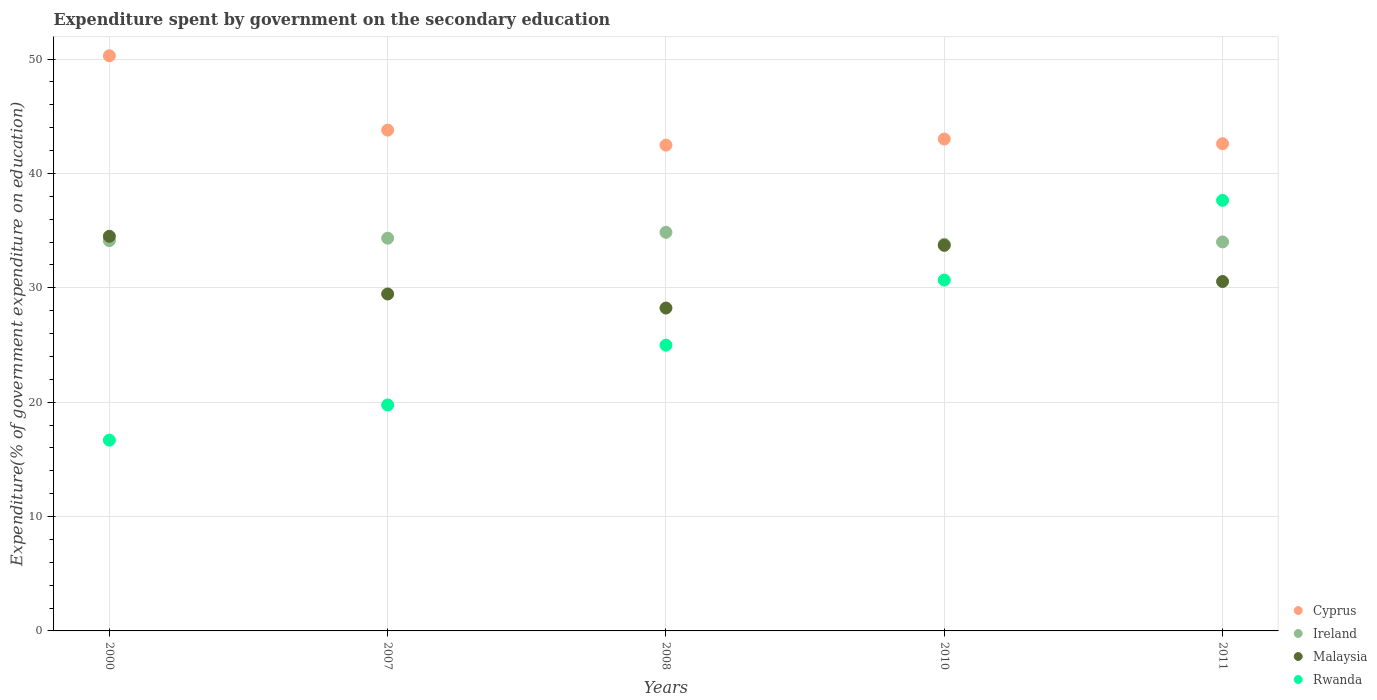What is the expenditure spent by government on the secondary education in Ireland in 2010?
Make the answer very short. 33.81. Across all years, what is the maximum expenditure spent by government on the secondary education in Rwanda?
Offer a very short reply. 37.65. Across all years, what is the minimum expenditure spent by government on the secondary education in Rwanda?
Make the answer very short. 16.68. In which year was the expenditure spent by government on the secondary education in Cyprus maximum?
Make the answer very short. 2000. In which year was the expenditure spent by government on the secondary education in Malaysia minimum?
Make the answer very short. 2008. What is the total expenditure spent by government on the secondary education in Cyprus in the graph?
Your answer should be compact. 222.17. What is the difference between the expenditure spent by government on the secondary education in Cyprus in 2000 and that in 2010?
Your answer should be very brief. 7.28. What is the difference between the expenditure spent by government on the secondary education in Ireland in 2008 and the expenditure spent by government on the secondary education in Rwanda in 2010?
Offer a very short reply. 4.18. What is the average expenditure spent by government on the secondary education in Rwanda per year?
Provide a short and direct response. 25.95. In the year 2000, what is the difference between the expenditure spent by government on the secondary education in Rwanda and expenditure spent by government on the secondary education in Ireland?
Your answer should be compact. -17.44. What is the ratio of the expenditure spent by government on the secondary education in Cyprus in 2000 to that in 2011?
Provide a short and direct response. 1.18. What is the difference between the highest and the second highest expenditure spent by government on the secondary education in Cyprus?
Your answer should be very brief. 6.5. What is the difference between the highest and the lowest expenditure spent by government on the secondary education in Ireland?
Make the answer very short. 1.04. Is it the case that in every year, the sum of the expenditure spent by government on the secondary education in Rwanda and expenditure spent by government on the secondary education in Malaysia  is greater than the expenditure spent by government on the secondary education in Ireland?
Your response must be concise. Yes. Does the expenditure spent by government on the secondary education in Malaysia monotonically increase over the years?
Ensure brevity in your answer.  No. How many dotlines are there?
Give a very brief answer. 4. How many years are there in the graph?
Offer a terse response. 5. Are the values on the major ticks of Y-axis written in scientific E-notation?
Give a very brief answer. No. How many legend labels are there?
Provide a short and direct response. 4. How are the legend labels stacked?
Your answer should be very brief. Vertical. What is the title of the graph?
Your answer should be very brief. Expenditure spent by government on the secondary education. Does "Cambodia" appear as one of the legend labels in the graph?
Your answer should be very brief. No. What is the label or title of the X-axis?
Your answer should be compact. Years. What is the label or title of the Y-axis?
Ensure brevity in your answer.  Expenditure(% of government expenditure on education). What is the Expenditure(% of government expenditure on education) in Cyprus in 2000?
Offer a terse response. 50.29. What is the Expenditure(% of government expenditure on education) in Ireland in 2000?
Provide a short and direct response. 34.13. What is the Expenditure(% of government expenditure on education) of Malaysia in 2000?
Make the answer very short. 34.51. What is the Expenditure(% of government expenditure on education) of Rwanda in 2000?
Provide a short and direct response. 16.68. What is the Expenditure(% of government expenditure on education) in Cyprus in 2007?
Keep it short and to the point. 43.79. What is the Expenditure(% of government expenditure on education) of Ireland in 2007?
Give a very brief answer. 34.34. What is the Expenditure(% of government expenditure on education) in Malaysia in 2007?
Make the answer very short. 29.46. What is the Expenditure(% of government expenditure on education) in Rwanda in 2007?
Your response must be concise. 19.76. What is the Expenditure(% of government expenditure on education) of Cyprus in 2008?
Your response must be concise. 42.48. What is the Expenditure(% of government expenditure on education) in Ireland in 2008?
Ensure brevity in your answer.  34.86. What is the Expenditure(% of government expenditure on education) of Malaysia in 2008?
Offer a terse response. 28.23. What is the Expenditure(% of government expenditure on education) in Rwanda in 2008?
Provide a short and direct response. 24.99. What is the Expenditure(% of government expenditure on education) in Cyprus in 2010?
Make the answer very short. 43.01. What is the Expenditure(% of government expenditure on education) in Ireland in 2010?
Provide a short and direct response. 33.81. What is the Expenditure(% of government expenditure on education) of Malaysia in 2010?
Your answer should be very brief. 33.72. What is the Expenditure(% of government expenditure on education) in Rwanda in 2010?
Keep it short and to the point. 30.68. What is the Expenditure(% of government expenditure on education) of Cyprus in 2011?
Keep it short and to the point. 42.6. What is the Expenditure(% of government expenditure on education) of Ireland in 2011?
Ensure brevity in your answer.  34.02. What is the Expenditure(% of government expenditure on education) in Malaysia in 2011?
Provide a short and direct response. 30.55. What is the Expenditure(% of government expenditure on education) of Rwanda in 2011?
Provide a short and direct response. 37.65. Across all years, what is the maximum Expenditure(% of government expenditure on education) in Cyprus?
Ensure brevity in your answer.  50.29. Across all years, what is the maximum Expenditure(% of government expenditure on education) in Ireland?
Provide a short and direct response. 34.86. Across all years, what is the maximum Expenditure(% of government expenditure on education) of Malaysia?
Ensure brevity in your answer.  34.51. Across all years, what is the maximum Expenditure(% of government expenditure on education) in Rwanda?
Offer a very short reply. 37.65. Across all years, what is the minimum Expenditure(% of government expenditure on education) in Cyprus?
Your answer should be compact. 42.48. Across all years, what is the minimum Expenditure(% of government expenditure on education) in Ireland?
Your answer should be very brief. 33.81. Across all years, what is the minimum Expenditure(% of government expenditure on education) of Malaysia?
Keep it short and to the point. 28.23. Across all years, what is the minimum Expenditure(% of government expenditure on education) of Rwanda?
Your response must be concise. 16.68. What is the total Expenditure(% of government expenditure on education) of Cyprus in the graph?
Ensure brevity in your answer.  222.17. What is the total Expenditure(% of government expenditure on education) of Ireland in the graph?
Your answer should be compact. 171.15. What is the total Expenditure(% of government expenditure on education) of Malaysia in the graph?
Offer a very short reply. 156.48. What is the total Expenditure(% of government expenditure on education) of Rwanda in the graph?
Offer a very short reply. 129.76. What is the difference between the Expenditure(% of government expenditure on education) in Cyprus in 2000 and that in 2007?
Your response must be concise. 6.5. What is the difference between the Expenditure(% of government expenditure on education) in Ireland in 2000 and that in 2007?
Provide a short and direct response. -0.21. What is the difference between the Expenditure(% of government expenditure on education) of Malaysia in 2000 and that in 2007?
Keep it short and to the point. 5.04. What is the difference between the Expenditure(% of government expenditure on education) of Rwanda in 2000 and that in 2007?
Your response must be concise. -3.08. What is the difference between the Expenditure(% of government expenditure on education) of Cyprus in 2000 and that in 2008?
Your response must be concise. 7.81. What is the difference between the Expenditure(% of government expenditure on education) in Ireland in 2000 and that in 2008?
Offer a very short reply. -0.73. What is the difference between the Expenditure(% of government expenditure on education) in Malaysia in 2000 and that in 2008?
Give a very brief answer. 6.27. What is the difference between the Expenditure(% of government expenditure on education) of Rwanda in 2000 and that in 2008?
Keep it short and to the point. -8.3. What is the difference between the Expenditure(% of government expenditure on education) of Cyprus in 2000 and that in 2010?
Your answer should be compact. 7.28. What is the difference between the Expenditure(% of government expenditure on education) of Ireland in 2000 and that in 2010?
Your answer should be compact. 0.31. What is the difference between the Expenditure(% of government expenditure on education) in Malaysia in 2000 and that in 2010?
Ensure brevity in your answer.  0.79. What is the difference between the Expenditure(% of government expenditure on education) in Rwanda in 2000 and that in 2010?
Provide a succinct answer. -14. What is the difference between the Expenditure(% of government expenditure on education) of Cyprus in 2000 and that in 2011?
Provide a succinct answer. 7.69. What is the difference between the Expenditure(% of government expenditure on education) of Ireland in 2000 and that in 2011?
Make the answer very short. 0.11. What is the difference between the Expenditure(% of government expenditure on education) in Malaysia in 2000 and that in 2011?
Your answer should be very brief. 3.95. What is the difference between the Expenditure(% of government expenditure on education) of Rwanda in 2000 and that in 2011?
Keep it short and to the point. -20.97. What is the difference between the Expenditure(% of government expenditure on education) in Cyprus in 2007 and that in 2008?
Provide a succinct answer. 1.31. What is the difference between the Expenditure(% of government expenditure on education) of Ireland in 2007 and that in 2008?
Make the answer very short. -0.52. What is the difference between the Expenditure(% of government expenditure on education) in Malaysia in 2007 and that in 2008?
Your answer should be compact. 1.23. What is the difference between the Expenditure(% of government expenditure on education) in Rwanda in 2007 and that in 2008?
Keep it short and to the point. -5.23. What is the difference between the Expenditure(% of government expenditure on education) of Cyprus in 2007 and that in 2010?
Provide a short and direct response. 0.78. What is the difference between the Expenditure(% of government expenditure on education) of Ireland in 2007 and that in 2010?
Keep it short and to the point. 0.53. What is the difference between the Expenditure(% of government expenditure on education) of Malaysia in 2007 and that in 2010?
Your answer should be very brief. -4.25. What is the difference between the Expenditure(% of government expenditure on education) of Rwanda in 2007 and that in 2010?
Keep it short and to the point. -10.92. What is the difference between the Expenditure(% of government expenditure on education) in Cyprus in 2007 and that in 2011?
Your answer should be compact. 1.19. What is the difference between the Expenditure(% of government expenditure on education) in Ireland in 2007 and that in 2011?
Give a very brief answer. 0.33. What is the difference between the Expenditure(% of government expenditure on education) in Malaysia in 2007 and that in 2011?
Keep it short and to the point. -1.09. What is the difference between the Expenditure(% of government expenditure on education) in Rwanda in 2007 and that in 2011?
Offer a terse response. -17.89. What is the difference between the Expenditure(% of government expenditure on education) in Cyprus in 2008 and that in 2010?
Give a very brief answer. -0.53. What is the difference between the Expenditure(% of government expenditure on education) of Ireland in 2008 and that in 2010?
Provide a short and direct response. 1.04. What is the difference between the Expenditure(% of government expenditure on education) in Malaysia in 2008 and that in 2010?
Make the answer very short. -5.48. What is the difference between the Expenditure(% of government expenditure on education) in Rwanda in 2008 and that in 2010?
Offer a very short reply. -5.69. What is the difference between the Expenditure(% of government expenditure on education) in Cyprus in 2008 and that in 2011?
Keep it short and to the point. -0.12. What is the difference between the Expenditure(% of government expenditure on education) in Ireland in 2008 and that in 2011?
Your response must be concise. 0.84. What is the difference between the Expenditure(% of government expenditure on education) of Malaysia in 2008 and that in 2011?
Your answer should be very brief. -2.32. What is the difference between the Expenditure(% of government expenditure on education) in Rwanda in 2008 and that in 2011?
Give a very brief answer. -12.66. What is the difference between the Expenditure(% of government expenditure on education) of Cyprus in 2010 and that in 2011?
Keep it short and to the point. 0.41. What is the difference between the Expenditure(% of government expenditure on education) in Ireland in 2010 and that in 2011?
Give a very brief answer. -0.2. What is the difference between the Expenditure(% of government expenditure on education) in Malaysia in 2010 and that in 2011?
Your answer should be very brief. 3.16. What is the difference between the Expenditure(% of government expenditure on education) of Rwanda in 2010 and that in 2011?
Provide a succinct answer. -6.97. What is the difference between the Expenditure(% of government expenditure on education) of Cyprus in 2000 and the Expenditure(% of government expenditure on education) of Ireland in 2007?
Your response must be concise. 15.95. What is the difference between the Expenditure(% of government expenditure on education) of Cyprus in 2000 and the Expenditure(% of government expenditure on education) of Malaysia in 2007?
Keep it short and to the point. 20.83. What is the difference between the Expenditure(% of government expenditure on education) of Cyprus in 2000 and the Expenditure(% of government expenditure on education) of Rwanda in 2007?
Keep it short and to the point. 30.53. What is the difference between the Expenditure(% of government expenditure on education) in Ireland in 2000 and the Expenditure(% of government expenditure on education) in Malaysia in 2007?
Offer a terse response. 4.66. What is the difference between the Expenditure(% of government expenditure on education) of Ireland in 2000 and the Expenditure(% of government expenditure on education) of Rwanda in 2007?
Give a very brief answer. 14.37. What is the difference between the Expenditure(% of government expenditure on education) in Malaysia in 2000 and the Expenditure(% of government expenditure on education) in Rwanda in 2007?
Offer a very short reply. 14.75. What is the difference between the Expenditure(% of government expenditure on education) of Cyprus in 2000 and the Expenditure(% of government expenditure on education) of Ireland in 2008?
Provide a succinct answer. 15.43. What is the difference between the Expenditure(% of government expenditure on education) in Cyprus in 2000 and the Expenditure(% of government expenditure on education) in Malaysia in 2008?
Keep it short and to the point. 22.06. What is the difference between the Expenditure(% of government expenditure on education) of Cyprus in 2000 and the Expenditure(% of government expenditure on education) of Rwanda in 2008?
Offer a terse response. 25.3. What is the difference between the Expenditure(% of government expenditure on education) in Ireland in 2000 and the Expenditure(% of government expenditure on education) in Malaysia in 2008?
Your response must be concise. 5.89. What is the difference between the Expenditure(% of government expenditure on education) of Ireland in 2000 and the Expenditure(% of government expenditure on education) of Rwanda in 2008?
Ensure brevity in your answer.  9.14. What is the difference between the Expenditure(% of government expenditure on education) in Malaysia in 2000 and the Expenditure(% of government expenditure on education) in Rwanda in 2008?
Offer a terse response. 9.52. What is the difference between the Expenditure(% of government expenditure on education) of Cyprus in 2000 and the Expenditure(% of government expenditure on education) of Ireland in 2010?
Offer a very short reply. 16.48. What is the difference between the Expenditure(% of government expenditure on education) in Cyprus in 2000 and the Expenditure(% of government expenditure on education) in Malaysia in 2010?
Offer a very short reply. 16.57. What is the difference between the Expenditure(% of government expenditure on education) of Cyprus in 2000 and the Expenditure(% of government expenditure on education) of Rwanda in 2010?
Your answer should be compact. 19.61. What is the difference between the Expenditure(% of government expenditure on education) in Ireland in 2000 and the Expenditure(% of government expenditure on education) in Malaysia in 2010?
Your response must be concise. 0.41. What is the difference between the Expenditure(% of government expenditure on education) in Ireland in 2000 and the Expenditure(% of government expenditure on education) in Rwanda in 2010?
Your answer should be compact. 3.45. What is the difference between the Expenditure(% of government expenditure on education) of Malaysia in 2000 and the Expenditure(% of government expenditure on education) of Rwanda in 2010?
Your answer should be very brief. 3.83. What is the difference between the Expenditure(% of government expenditure on education) of Cyprus in 2000 and the Expenditure(% of government expenditure on education) of Ireland in 2011?
Ensure brevity in your answer.  16.28. What is the difference between the Expenditure(% of government expenditure on education) of Cyprus in 2000 and the Expenditure(% of government expenditure on education) of Malaysia in 2011?
Keep it short and to the point. 19.74. What is the difference between the Expenditure(% of government expenditure on education) in Cyprus in 2000 and the Expenditure(% of government expenditure on education) in Rwanda in 2011?
Give a very brief answer. 12.64. What is the difference between the Expenditure(% of government expenditure on education) of Ireland in 2000 and the Expenditure(% of government expenditure on education) of Malaysia in 2011?
Keep it short and to the point. 3.57. What is the difference between the Expenditure(% of government expenditure on education) in Ireland in 2000 and the Expenditure(% of government expenditure on education) in Rwanda in 2011?
Your answer should be compact. -3.52. What is the difference between the Expenditure(% of government expenditure on education) of Malaysia in 2000 and the Expenditure(% of government expenditure on education) of Rwanda in 2011?
Provide a short and direct response. -3.14. What is the difference between the Expenditure(% of government expenditure on education) in Cyprus in 2007 and the Expenditure(% of government expenditure on education) in Ireland in 2008?
Provide a short and direct response. 8.93. What is the difference between the Expenditure(% of government expenditure on education) of Cyprus in 2007 and the Expenditure(% of government expenditure on education) of Malaysia in 2008?
Offer a very short reply. 15.56. What is the difference between the Expenditure(% of government expenditure on education) of Cyprus in 2007 and the Expenditure(% of government expenditure on education) of Rwanda in 2008?
Your answer should be very brief. 18.8. What is the difference between the Expenditure(% of government expenditure on education) in Ireland in 2007 and the Expenditure(% of government expenditure on education) in Malaysia in 2008?
Provide a succinct answer. 6.11. What is the difference between the Expenditure(% of government expenditure on education) in Ireland in 2007 and the Expenditure(% of government expenditure on education) in Rwanda in 2008?
Offer a terse response. 9.35. What is the difference between the Expenditure(% of government expenditure on education) of Malaysia in 2007 and the Expenditure(% of government expenditure on education) of Rwanda in 2008?
Offer a terse response. 4.48. What is the difference between the Expenditure(% of government expenditure on education) of Cyprus in 2007 and the Expenditure(% of government expenditure on education) of Ireland in 2010?
Your answer should be compact. 9.98. What is the difference between the Expenditure(% of government expenditure on education) in Cyprus in 2007 and the Expenditure(% of government expenditure on education) in Malaysia in 2010?
Provide a short and direct response. 10.07. What is the difference between the Expenditure(% of government expenditure on education) of Cyprus in 2007 and the Expenditure(% of government expenditure on education) of Rwanda in 2010?
Provide a short and direct response. 13.11. What is the difference between the Expenditure(% of government expenditure on education) in Ireland in 2007 and the Expenditure(% of government expenditure on education) in Malaysia in 2010?
Provide a short and direct response. 0.62. What is the difference between the Expenditure(% of government expenditure on education) in Ireland in 2007 and the Expenditure(% of government expenditure on education) in Rwanda in 2010?
Provide a short and direct response. 3.66. What is the difference between the Expenditure(% of government expenditure on education) in Malaysia in 2007 and the Expenditure(% of government expenditure on education) in Rwanda in 2010?
Provide a succinct answer. -1.22. What is the difference between the Expenditure(% of government expenditure on education) of Cyprus in 2007 and the Expenditure(% of government expenditure on education) of Ireland in 2011?
Provide a short and direct response. 9.77. What is the difference between the Expenditure(% of government expenditure on education) in Cyprus in 2007 and the Expenditure(% of government expenditure on education) in Malaysia in 2011?
Your response must be concise. 13.24. What is the difference between the Expenditure(% of government expenditure on education) of Cyprus in 2007 and the Expenditure(% of government expenditure on education) of Rwanda in 2011?
Offer a very short reply. 6.14. What is the difference between the Expenditure(% of government expenditure on education) in Ireland in 2007 and the Expenditure(% of government expenditure on education) in Malaysia in 2011?
Provide a succinct answer. 3.79. What is the difference between the Expenditure(% of government expenditure on education) of Ireland in 2007 and the Expenditure(% of government expenditure on education) of Rwanda in 2011?
Keep it short and to the point. -3.31. What is the difference between the Expenditure(% of government expenditure on education) in Malaysia in 2007 and the Expenditure(% of government expenditure on education) in Rwanda in 2011?
Your answer should be very brief. -8.19. What is the difference between the Expenditure(% of government expenditure on education) in Cyprus in 2008 and the Expenditure(% of government expenditure on education) in Ireland in 2010?
Make the answer very short. 8.67. What is the difference between the Expenditure(% of government expenditure on education) of Cyprus in 2008 and the Expenditure(% of government expenditure on education) of Malaysia in 2010?
Ensure brevity in your answer.  8.76. What is the difference between the Expenditure(% of government expenditure on education) of Cyprus in 2008 and the Expenditure(% of government expenditure on education) of Rwanda in 2010?
Your answer should be compact. 11.8. What is the difference between the Expenditure(% of government expenditure on education) of Ireland in 2008 and the Expenditure(% of government expenditure on education) of Malaysia in 2010?
Provide a short and direct response. 1.14. What is the difference between the Expenditure(% of government expenditure on education) of Ireland in 2008 and the Expenditure(% of government expenditure on education) of Rwanda in 2010?
Offer a terse response. 4.18. What is the difference between the Expenditure(% of government expenditure on education) of Malaysia in 2008 and the Expenditure(% of government expenditure on education) of Rwanda in 2010?
Offer a very short reply. -2.45. What is the difference between the Expenditure(% of government expenditure on education) of Cyprus in 2008 and the Expenditure(% of government expenditure on education) of Ireland in 2011?
Your answer should be very brief. 8.46. What is the difference between the Expenditure(% of government expenditure on education) in Cyprus in 2008 and the Expenditure(% of government expenditure on education) in Malaysia in 2011?
Provide a succinct answer. 11.92. What is the difference between the Expenditure(% of government expenditure on education) in Cyprus in 2008 and the Expenditure(% of government expenditure on education) in Rwanda in 2011?
Give a very brief answer. 4.83. What is the difference between the Expenditure(% of government expenditure on education) in Ireland in 2008 and the Expenditure(% of government expenditure on education) in Malaysia in 2011?
Ensure brevity in your answer.  4.3. What is the difference between the Expenditure(% of government expenditure on education) of Ireland in 2008 and the Expenditure(% of government expenditure on education) of Rwanda in 2011?
Offer a terse response. -2.79. What is the difference between the Expenditure(% of government expenditure on education) of Malaysia in 2008 and the Expenditure(% of government expenditure on education) of Rwanda in 2011?
Make the answer very short. -9.42. What is the difference between the Expenditure(% of government expenditure on education) of Cyprus in 2010 and the Expenditure(% of government expenditure on education) of Ireland in 2011?
Ensure brevity in your answer.  9. What is the difference between the Expenditure(% of government expenditure on education) in Cyprus in 2010 and the Expenditure(% of government expenditure on education) in Malaysia in 2011?
Provide a succinct answer. 12.46. What is the difference between the Expenditure(% of government expenditure on education) in Cyprus in 2010 and the Expenditure(% of government expenditure on education) in Rwanda in 2011?
Keep it short and to the point. 5.36. What is the difference between the Expenditure(% of government expenditure on education) in Ireland in 2010 and the Expenditure(% of government expenditure on education) in Malaysia in 2011?
Give a very brief answer. 3.26. What is the difference between the Expenditure(% of government expenditure on education) of Ireland in 2010 and the Expenditure(% of government expenditure on education) of Rwanda in 2011?
Offer a very short reply. -3.84. What is the difference between the Expenditure(% of government expenditure on education) in Malaysia in 2010 and the Expenditure(% of government expenditure on education) in Rwanda in 2011?
Your answer should be very brief. -3.93. What is the average Expenditure(% of government expenditure on education) in Cyprus per year?
Your response must be concise. 44.43. What is the average Expenditure(% of government expenditure on education) in Ireland per year?
Ensure brevity in your answer.  34.23. What is the average Expenditure(% of government expenditure on education) of Malaysia per year?
Make the answer very short. 31.3. What is the average Expenditure(% of government expenditure on education) in Rwanda per year?
Keep it short and to the point. 25.95. In the year 2000, what is the difference between the Expenditure(% of government expenditure on education) of Cyprus and Expenditure(% of government expenditure on education) of Ireland?
Make the answer very short. 16.16. In the year 2000, what is the difference between the Expenditure(% of government expenditure on education) of Cyprus and Expenditure(% of government expenditure on education) of Malaysia?
Offer a terse response. 15.78. In the year 2000, what is the difference between the Expenditure(% of government expenditure on education) in Cyprus and Expenditure(% of government expenditure on education) in Rwanda?
Your answer should be very brief. 33.61. In the year 2000, what is the difference between the Expenditure(% of government expenditure on education) of Ireland and Expenditure(% of government expenditure on education) of Malaysia?
Give a very brief answer. -0.38. In the year 2000, what is the difference between the Expenditure(% of government expenditure on education) in Ireland and Expenditure(% of government expenditure on education) in Rwanda?
Offer a terse response. 17.44. In the year 2000, what is the difference between the Expenditure(% of government expenditure on education) of Malaysia and Expenditure(% of government expenditure on education) of Rwanda?
Provide a succinct answer. 17.82. In the year 2007, what is the difference between the Expenditure(% of government expenditure on education) in Cyprus and Expenditure(% of government expenditure on education) in Ireland?
Offer a terse response. 9.45. In the year 2007, what is the difference between the Expenditure(% of government expenditure on education) in Cyprus and Expenditure(% of government expenditure on education) in Malaysia?
Keep it short and to the point. 14.33. In the year 2007, what is the difference between the Expenditure(% of government expenditure on education) in Cyprus and Expenditure(% of government expenditure on education) in Rwanda?
Offer a very short reply. 24.03. In the year 2007, what is the difference between the Expenditure(% of government expenditure on education) of Ireland and Expenditure(% of government expenditure on education) of Malaysia?
Offer a very short reply. 4.88. In the year 2007, what is the difference between the Expenditure(% of government expenditure on education) in Ireland and Expenditure(% of government expenditure on education) in Rwanda?
Offer a very short reply. 14.58. In the year 2007, what is the difference between the Expenditure(% of government expenditure on education) in Malaysia and Expenditure(% of government expenditure on education) in Rwanda?
Your answer should be compact. 9.7. In the year 2008, what is the difference between the Expenditure(% of government expenditure on education) of Cyprus and Expenditure(% of government expenditure on education) of Ireland?
Your response must be concise. 7.62. In the year 2008, what is the difference between the Expenditure(% of government expenditure on education) in Cyprus and Expenditure(% of government expenditure on education) in Malaysia?
Make the answer very short. 14.24. In the year 2008, what is the difference between the Expenditure(% of government expenditure on education) in Cyprus and Expenditure(% of government expenditure on education) in Rwanda?
Ensure brevity in your answer.  17.49. In the year 2008, what is the difference between the Expenditure(% of government expenditure on education) in Ireland and Expenditure(% of government expenditure on education) in Malaysia?
Keep it short and to the point. 6.62. In the year 2008, what is the difference between the Expenditure(% of government expenditure on education) in Ireland and Expenditure(% of government expenditure on education) in Rwanda?
Make the answer very short. 9.87. In the year 2008, what is the difference between the Expenditure(% of government expenditure on education) in Malaysia and Expenditure(% of government expenditure on education) in Rwanda?
Offer a very short reply. 3.25. In the year 2010, what is the difference between the Expenditure(% of government expenditure on education) of Cyprus and Expenditure(% of government expenditure on education) of Ireland?
Your response must be concise. 9.2. In the year 2010, what is the difference between the Expenditure(% of government expenditure on education) of Cyprus and Expenditure(% of government expenditure on education) of Malaysia?
Provide a short and direct response. 9.29. In the year 2010, what is the difference between the Expenditure(% of government expenditure on education) in Cyprus and Expenditure(% of government expenditure on education) in Rwanda?
Provide a short and direct response. 12.33. In the year 2010, what is the difference between the Expenditure(% of government expenditure on education) of Ireland and Expenditure(% of government expenditure on education) of Malaysia?
Ensure brevity in your answer.  0.1. In the year 2010, what is the difference between the Expenditure(% of government expenditure on education) of Ireland and Expenditure(% of government expenditure on education) of Rwanda?
Your answer should be compact. 3.13. In the year 2010, what is the difference between the Expenditure(% of government expenditure on education) of Malaysia and Expenditure(% of government expenditure on education) of Rwanda?
Offer a terse response. 3.04. In the year 2011, what is the difference between the Expenditure(% of government expenditure on education) in Cyprus and Expenditure(% of government expenditure on education) in Ireland?
Your answer should be very brief. 8.59. In the year 2011, what is the difference between the Expenditure(% of government expenditure on education) in Cyprus and Expenditure(% of government expenditure on education) in Malaysia?
Offer a terse response. 12.05. In the year 2011, what is the difference between the Expenditure(% of government expenditure on education) in Cyprus and Expenditure(% of government expenditure on education) in Rwanda?
Offer a terse response. 4.95. In the year 2011, what is the difference between the Expenditure(% of government expenditure on education) of Ireland and Expenditure(% of government expenditure on education) of Malaysia?
Keep it short and to the point. 3.46. In the year 2011, what is the difference between the Expenditure(% of government expenditure on education) in Ireland and Expenditure(% of government expenditure on education) in Rwanda?
Provide a short and direct response. -3.63. In the year 2011, what is the difference between the Expenditure(% of government expenditure on education) of Malaysia and Expenditure(% of government expenditure on education) of Rwanda?
Your response must be concise. -7.1. What is the ratio of the Expenditure(% of government expenditure on education) of Cyprus in 2000 to that in 2007?
Provide a succinct answer. 1.15. What is the ratio of the Expenditure(% of government expenditure on education) of Malaysia in 2000 to that in 2007?
Keep it short and to the point. 1.17. What is the ratio of the Expenditure(% of government expenditure on education) of Rwanda in 2000 to that in 2007?
Give a very brief answer. 0.84. What is the ratio of the Expenditure(% of government expenditure on education) of Cyprus in 2000 to that in 2008?
Your answer should be compact. 1.18. What is the ratio of the Expenditure(% of government expenditure on education) of Ireland in 2000 to that in 2008?
Your answer should be very brief. 0.98. What is the ratio of the Expenditure(% of government expenditure on education) of Malaysia in 2000 to that in 2008?
Keep it short and to the point. 1.22. What is the ratio of the Expenditure(% of government expenditure on education) of Rwanda in 2000 to that in 2008?
Make the answer very short. 0.67. What is the ratio of the Expenditure(% of government expenditure on education) of Cyprus in 2000 to that in 2010?
Your response must be concise. 1.17. What is the ratio of the Expenditure(% of government expenditure on education) of Ireland in 2000 to that in 2010?
Give a very brief answer. 1.01. What is the ratio of the Expenditure(% of government expenditure on education) in Malaysia in 2000 to that in 2010?
Your answer should be very brief. 1.02. What is the ratio of the Expenditure(% of government expenditure on education) in Rwanda in 2000 to that in 2010?
Your answer should be compact. 0.54. What is the ratio of the Expenditure(% of government expenditure on education) of Cyprus in 2000 to that in 2011?
Make the answer very short. 1.18. What is the ratio of the Expenditure(% of government expenditure on education) in Ireland in 2000 to that in 2011?
Keep it short and to the point. 1. What is the ratio of the Expenditure(% of government expenditure on education) of Malaysia in 2000 to that in 2011?
Give a very brief answer. 1.13. What is the ratio of the Expenditure(% of government expenditure on education) in Rwanda in 2000 to that in 2011?
Provide a short and direct response. 0.44. What is the ratio of the Expenditure(% of government expenditure on education) of Cyprus in 2007 to that in 2008?
Provide a short and direct response. 1.03. What is the ratio of the Expenditure(% of government expenditure on education) in Ireland in 2007 to that in 2008?
Provide a succinct answer. 0.99. What is the ratio of the Expenditure(% of government expenditure on education) of Malaysia in 2007 to that in 2008?
Provide a short and direct response. 1.04. What is the ratio of the Expenditure(% of government expenditure on education) of Rwanda in 2007 to that in 2008?
Ensure brevity in your answer.  0.79. What is the ratio of the Expenditure(% of government expenditure on education) in Cyprus in 2007 to that in 2010?
Give a very brief answer. 1.02. What is the ratio of the Expenditure(% of government expenditure on education) of Ireland in 2007 to that in 2010?
Provide a short and direct response. 1.02. What is the ratio of the Expenditure(% of government expenditure on education) of Malaysia in 2007 to that in 2010?
Make the answer very short. 0.87. What is the ratio of the Expenditure(% of government expenditure on education) in Rwanda in 2007 to that in 2010?
Provide a succinct answer. 0.64. What is the ratio of the Expenditure(% of government expenditure on education) in Cyprus in 2007 to that in 2011?
Offer a terse response. 1.03. What is the ratio of the Expenditure(% of government expenditure on education) in Ireland in 2007 to that in 2011?
Offer a very short reply. 1.01. What is the ratio of the Expenditure(% of government expenditure on education) in Malaysia in 2007 to that in 2011?
Ensure brevity in your answer.  0.96. What is the ratio of the Expenditure(% of government expenditure on education) in Rwanda in 2007 to that in 2011?
Give a very brief answer. 0.52. What is the ratio of the Expenditure(% of government expenditure on education) in Cyprus in 2008 to that in 2010?
Make the answer very short. 0.99. What is the ratio of the Expenditure(% of government expenditure on education) in Ireland in 2008 to that in 2010?
Make the answer very short. 1.03. What is the ratio of the Expenditure(% of government expenditure on education) of Malaysia in 2008 to that in 2010?
Make the answer very short. 0.84. What is the ratio of the Expenditure(% of government expenditure on education) in Rwanda in 2008 to that in 2010?
Ensure brevity in your answer.  0.81. What is the ratio of the Expenditure(% of government expenditure on education) in Ireland in 2008 to that in 2011?
Your answer should be very brief. 1.02. What is the ratio of the Expenditure(% of government expenditure on education) of Malaysia in 2008 to that in 2011?
Make the answer very short. 0.92. What is the ratio of the Expenditure(% of government expenditure on education) of Rwanda in 2008 to that in 2011?
Give a very brief answer. 0.66. What is the ratio of the Expenditure(% of government expenditure on education) of Cyprus in 2010 to that in 2011?
Ensure brevity in your answer.  1.01. What is the ratio of the Expenditure(% of government expenditure on education) in Malaysia in 2010 to that in 2011?
Ensure brevity in your answer.  1.1. What is the ratio of the Expenditure(% of government expenditure on education) in Rwanda in 2010 to that in 2011?
Offer a terse response. 0.81. What is the difference between the highest and the second highest Expenditure(% of government expenditure on education) in Cyprus?
Offer a terse response. 6.5. What is the difference between the highest and the second highest Expenditure(% of government expenditure on education) of Ireland?
Make the answer very short. 0.52. What is the difference between the highest and the second highest Expenditure(% of government expenditure on education) in Malaysia?
Provide a short and direct response. 0.79. What is the difference between the highest and the second highest Expenditure(% of government expenditure on education) of Rwanda?
Offer a very short reply. 6.97. What is the difference between the highest and the lowest Expenditure(% of government expenditure on education) in Cyprus?
Make the answer very short. 7.81. What is the difference between the highest and the lowest Expenditure(% of government expenditure on education) of Ireland?
Provide a short and direct response. 1.04. What is the difference between the highest and the lowest Expenditure(% of government expenditure on education) of Malaysia?
Keep it short and to the point. 6.27. What is the difference between the highest and the lowest Expenditure(% of government expenditure on education) of Rwanda?
Make the answer very short. 20.97. 